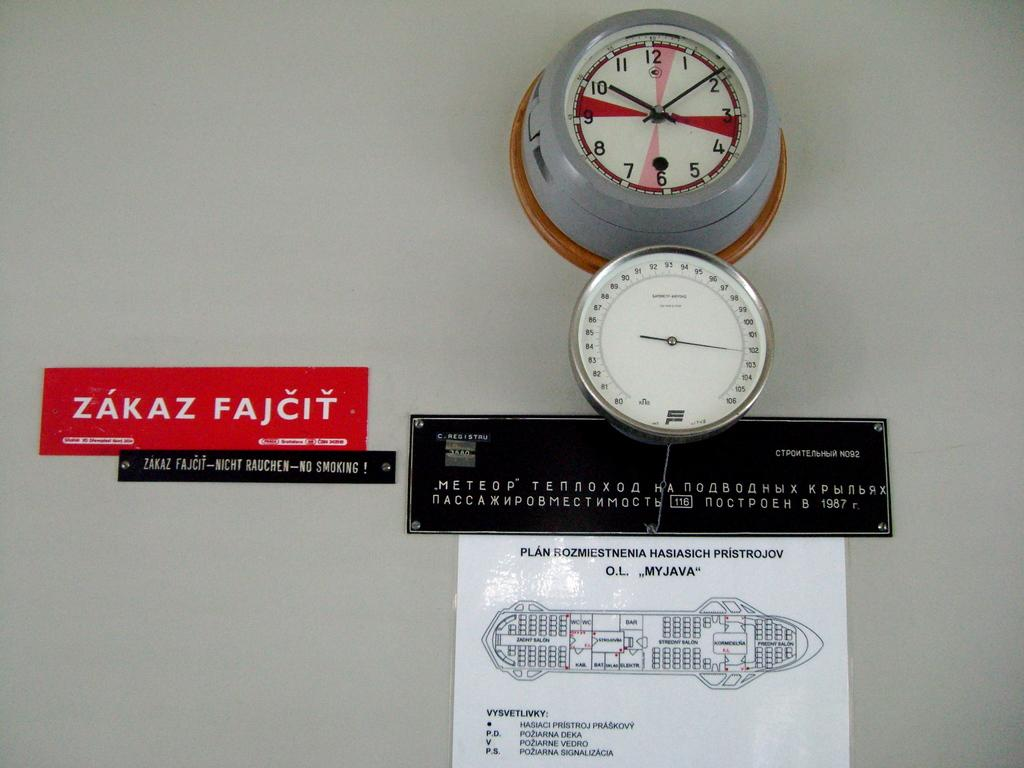<image>
Create a compact narrative representing the image presented. A clock and a guage and a map on the wall with a red sticker that says Zakaz Fajcit. 